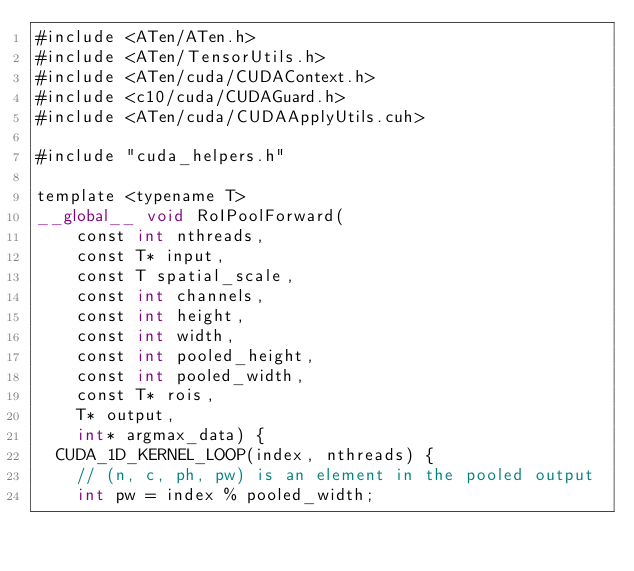<code> <loc_0><loc_0><loc_500><loc_500><_Cuda_>#include <ATen/ATen.h>
#include <ATen/TensorUtils.h>
#include <ATen/cuda/CUDAContext.h>
#include <c10/cuda/CUDAGuard.h>
#include <ATen/cuda/CUDAApplyUtils.cuh>

#include "cuda_helpers.h"

template <typename T>
__global__ void RoIPoolForward(
    const int nthreads,
    const T* input,
    const T spatial_scale,
    const int channels,
    const int height,
    const int width,
    const int pooled_height,
    const int pooled_width,
    const T* rois,
    T* output,
    int* argmax_data) {
  CUDA_1D_KERNEL_LOOP(index, nthreads) {
    // (n, c, ph, pw) is an element in the pooled output
    int pw = index % pooled_width;</code> 